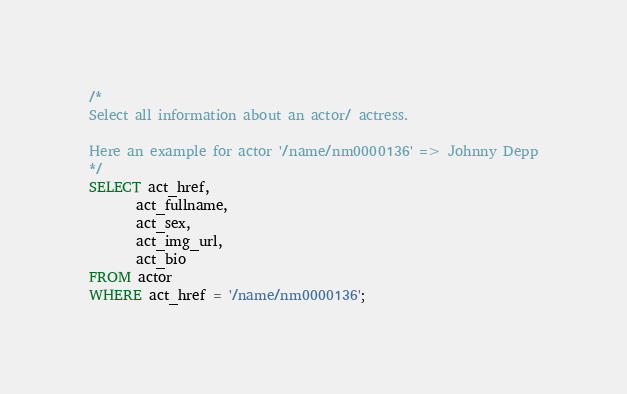Convert code to text. <code><loc_0><loc_0><loc_500><loc_500><_SQL_>/*
Select all information about an actor/ actress.

Here an example for actor '/name/nm0000136' => Johnny Depp
*/
SELECT act_href,
	   act_fullname,
	   act_sex,
	   act_img_url,
	   act_bio
FROM actor
WHERE act_href = '/name/nm0000136';</code> 